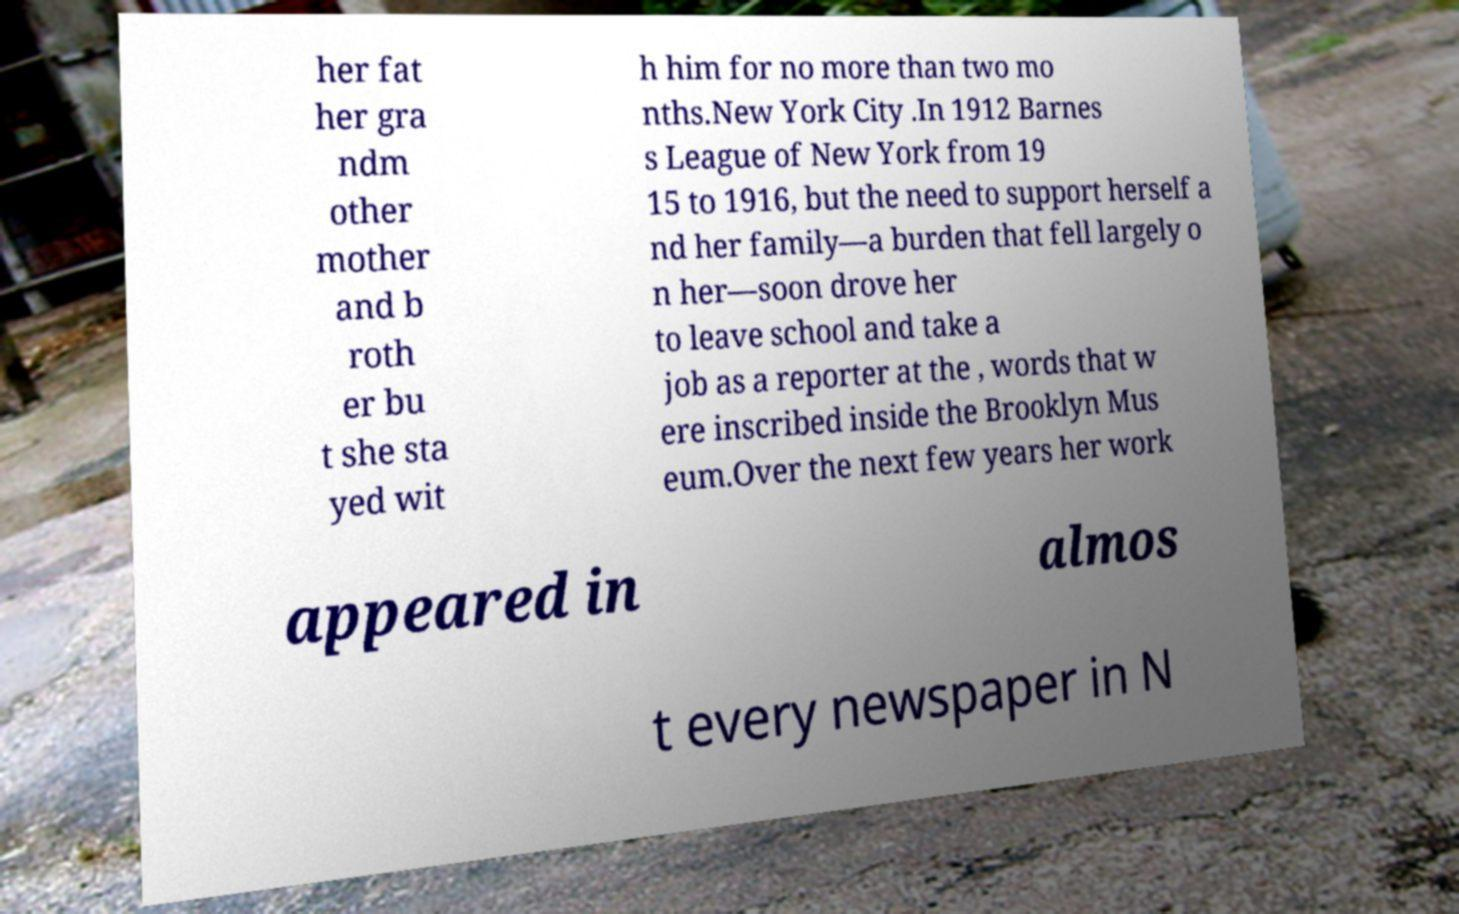I need the written content from this picture converted into text. Can you do that? her fat her gra ndm other mother and b roth er bu t she sta yed wit h him for no more than two mo nths.New York City .In 1912 Barnes s League of New York from 19 15 to 1916, but the need to support herself a nd her family—a burden that fell largely o n her—soon drove her to leave school and take a job as a reporter at the , words that w ere inscribed inside the Brooklyn Mus eum.Over the next few years her work appeared in almos t every newspaper in N 